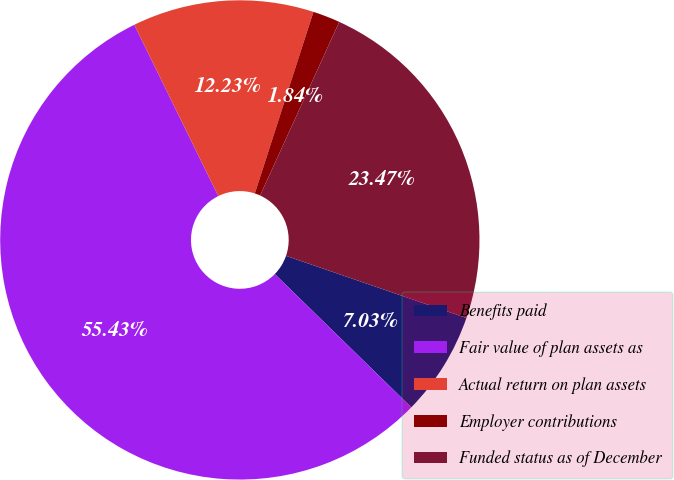Convert chart. <chart><loc_0><loc_0><loc_500><loc_500><pie_chart><fcel>Benefits paid<fcel>Fair value of plan assets as<fcel>Actual return on plan assets<fcel>Employer contributions<fcel>Funded status as of December<nl><fcel>7.03%<fcel>55.43%<fcel>12.23%<fcel>1.84%<fcel>23.47%<nl></chart> 